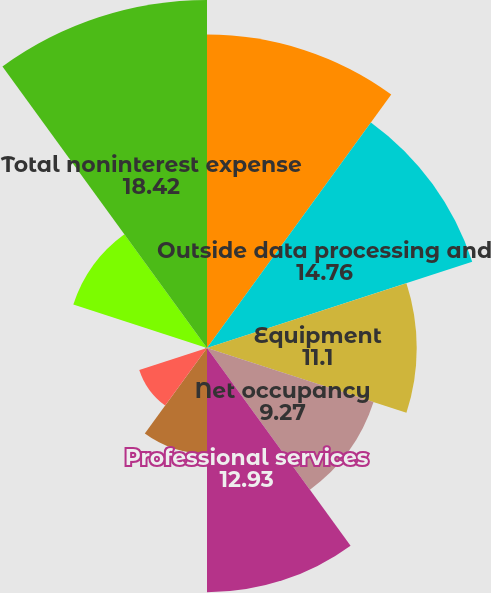Convert chart to OTSL. <chart><loc_0><loc_0><loc_500><loc_500><pie_chart><fcel>Personnel costs<fcel>Outside data processing and<fcel>Equipment<fcel>Net occupancy<fcel>Professional services<fcel>Marketing<fcel>Deposit and other insurance<fcel>Amortization of intangibles<fcel>Other expense<fcel>Total noninterest expense<nl><fcel>16.59%<fcel>14.76%<fcel>11.1%<fcel>9.27%<fcel>12.93%<fcel>5.6%<fcel>3.77%<fcel>0.11%<fcel>7.44%<fcel>18.42%<nl></chart> 